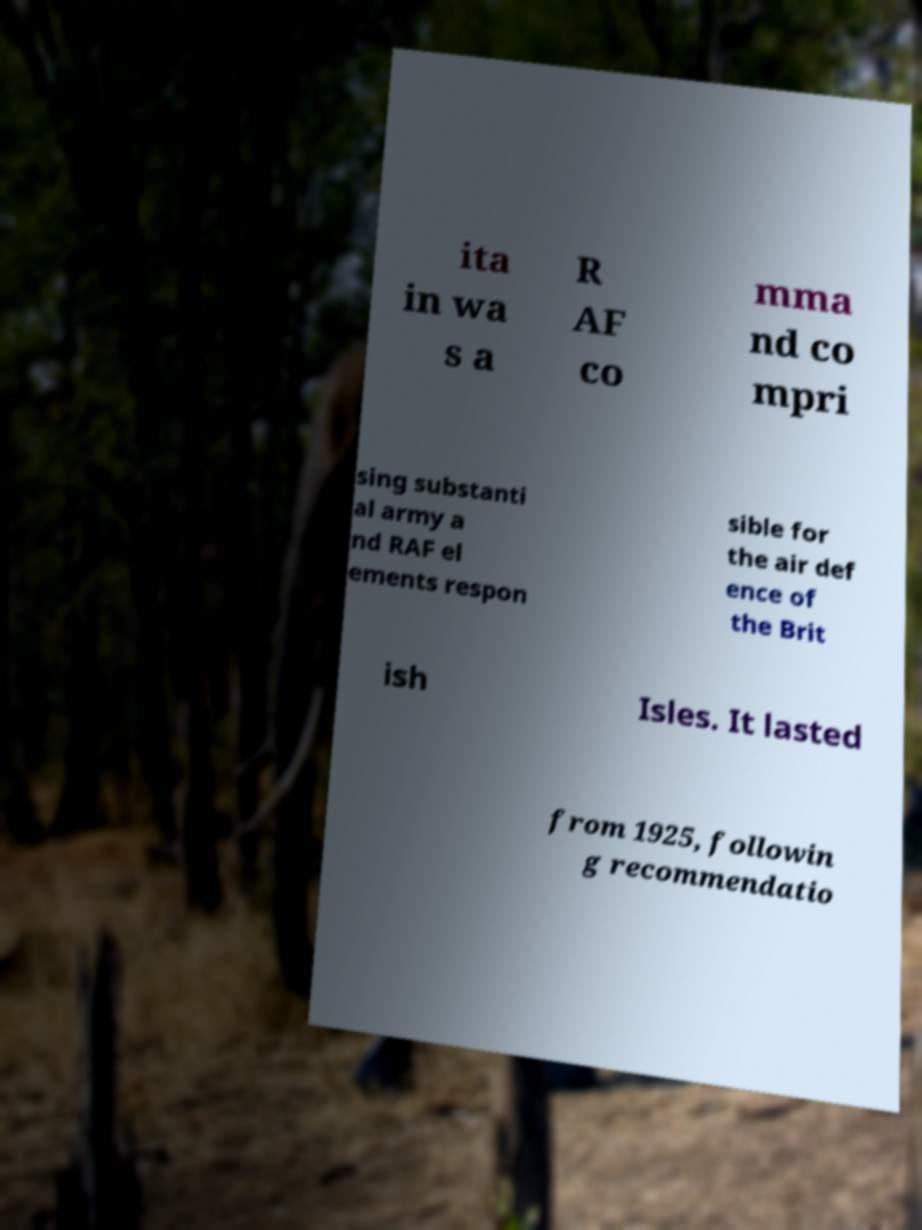Please read and relay the text visible in this image. What does it say? ita in wa s a R AF co mma nd co mpri sing substanti al army a nd RAF el ements respon sible for the air def ence of the Brit ish Isles. It lasted from 1925, followin g recommendatio 